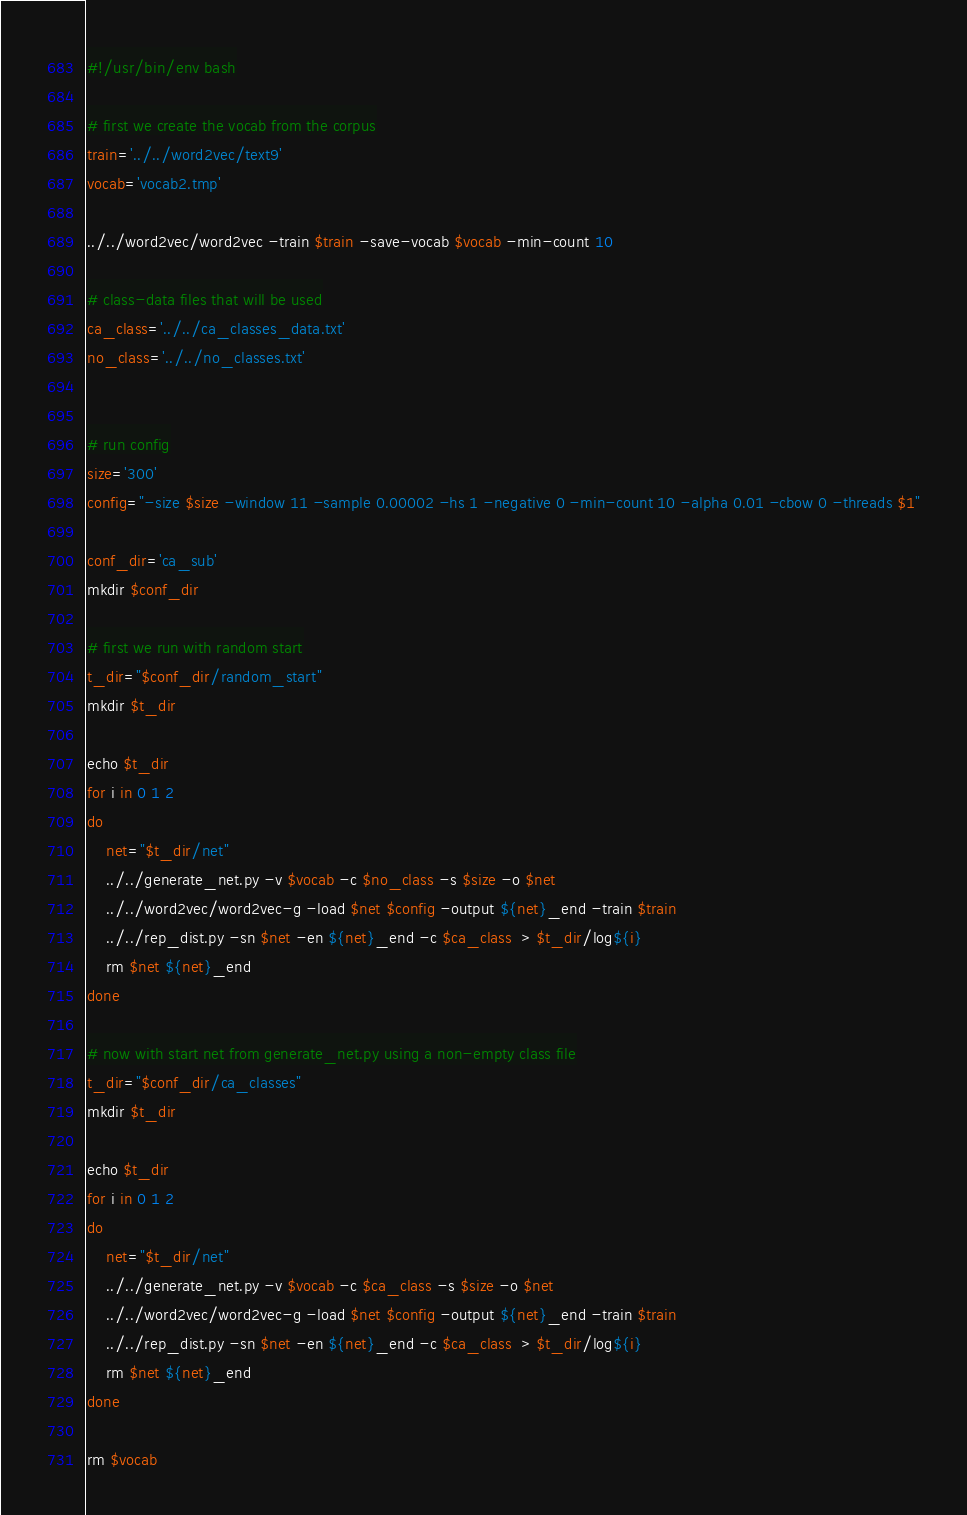Convert code to text. <code><loc_0><loc_0><loc_500><loc_500><_Bash_>#!/usr/bin/env bash

# first we create the vocab from the corpus
train='../../word2vec/text9'
vocab='vocab2.tmp'

../../word2vec/word2vec -train $train -save-vocab $vocab -min-count 10

# class-data files that will be used
ca_class='../../ca_classes_data.txt'
no_class='../../no_classes.txt'


# run config
size='300'
config="-size $size -window 11 -sample 0.00002 -hs 1 -negative 0 -min-count 10 -alpha 0.01 -cbow 0 -threads $1"

conf_dir='ca_sub'
mkdir $conf_dir

# first we run with random start
t_dir="$conf_dir/random_start"
mkdir $t_dir

echo $t_dir
for i in 0 1 2
do
	net="$t_dir/net"
	../../generate_net.py -v $vocab -c $no_class -s $size -o $net
	../../word2vec/word2vec-g -load $net $config -output ${net}_end -train $train
	../../rep_dist.py -sn $net -en ${net}_end -c $ca_class  > $t_dir/log${i}
	rm $net ${net}_end
done

# now with start net from generate_net.py using a non-empty class file
t_dir="$conf_dir/ca_classes"
mkdir $t_dir

echo $t_dir
for i in 0 1 2 
do
	net="$t_dir/net"
	../../generate_net.py -v $vocab -c $ca_class -s $size -o $net
	../../word2vec/word2vec-g -load $net $config -output ${net}_end -train $train
	../../rep_dist.py -sn $net -en ${net}_end -c $ca_class  > $t_dir/log${i}
	rm $net ${net}_end
done

rm $vocab
</code> 